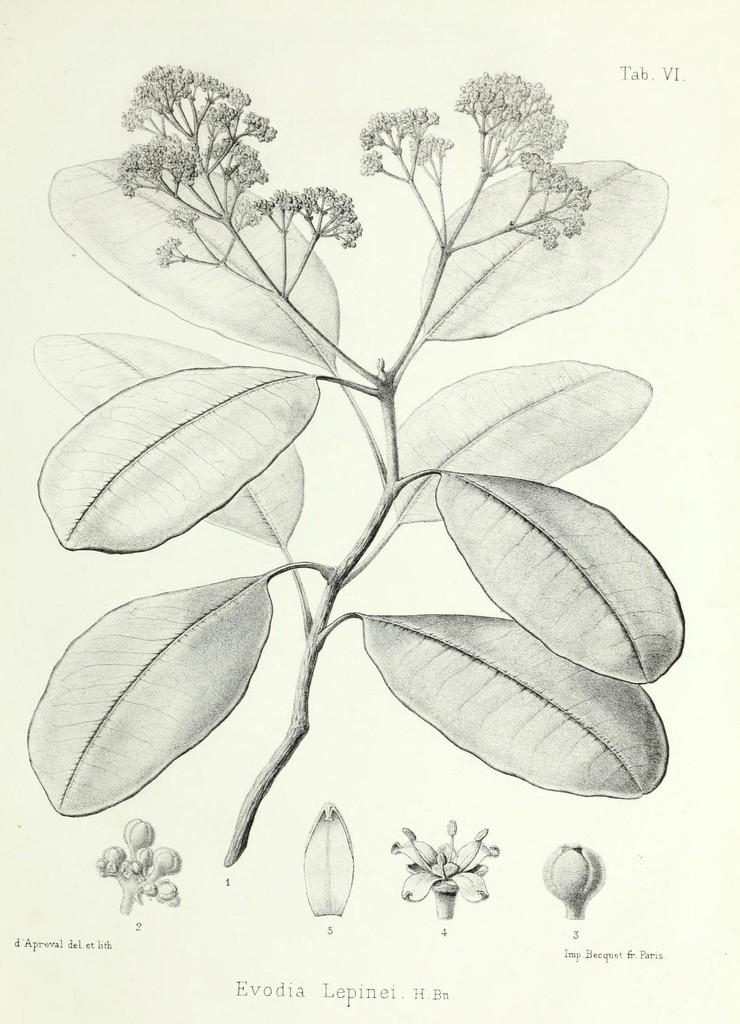What is depicted in the image? There is a plant in the image. What features can be observed on the plant? The plant has leaves and buds. How is the image created? The image is a drawing. What type of business is being conducted in the image? There is no indication of any business activity in the image, as it features a drawing of a plant. What view can be seen from the plant's perspective in the image? The image does not provide a view from the plant's perspective, as it is a drawing of a plant and not a photograph. 